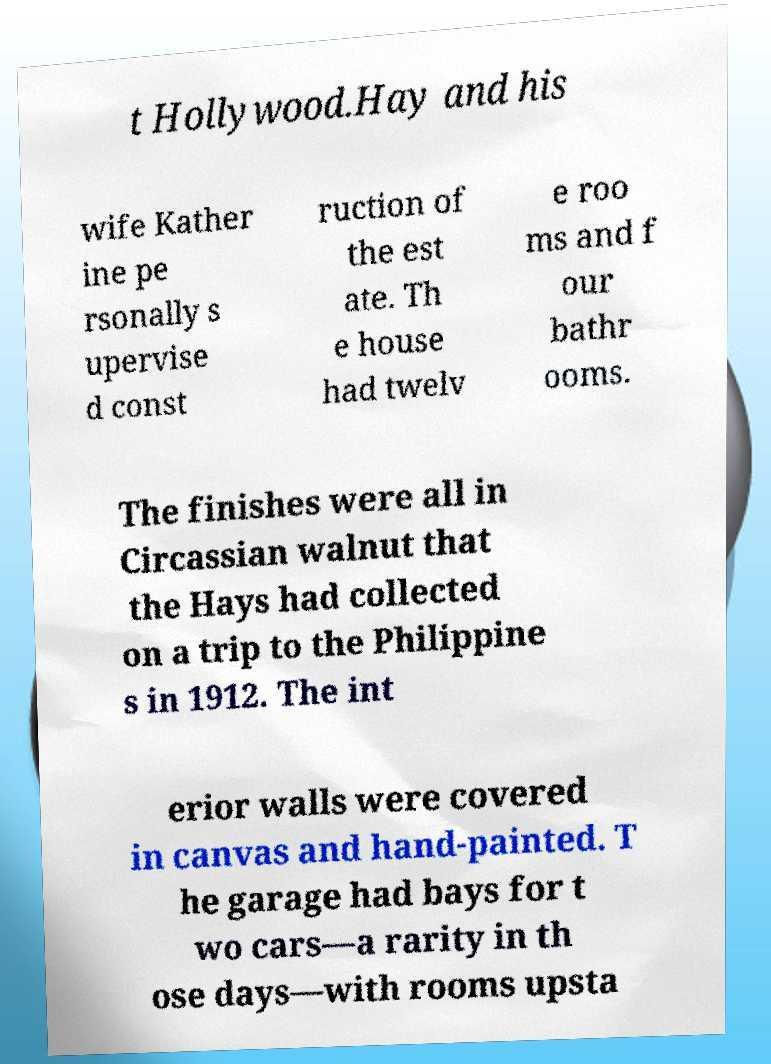What messages or text are displayed in this image? I need them in a readable, typed format. t Hollywood.Hay and his wife Kather ine pe rsonally s upervise d const ruction of the est ate. Th e house had twelv e roo ms and f our bathr ooms. The finishes were all in Circassian walnut that the Hays had collected on a trip to the Philippine s in 1912. The int erior walls were covered in canvas and hand-painted. T he garage had bays for t wo cars—a rarity in th ose days—with rooms upsta 